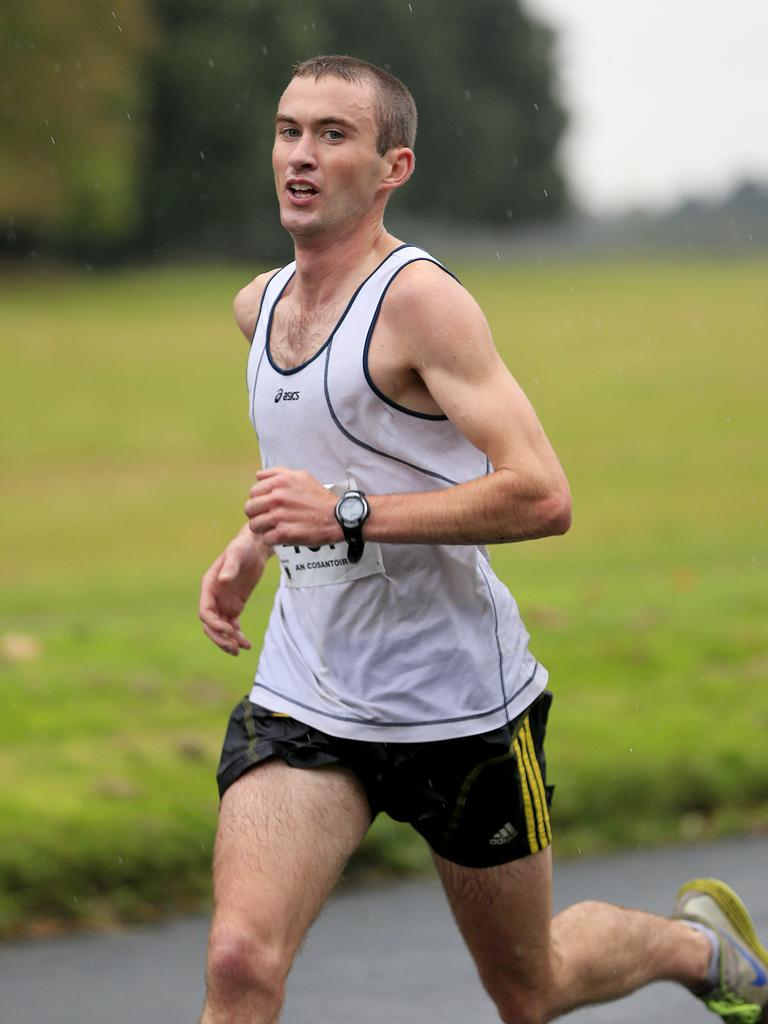<image>
Present a compact description of the photo's key features. Runner running in the rain wearing a tanktop that says ASICS. 